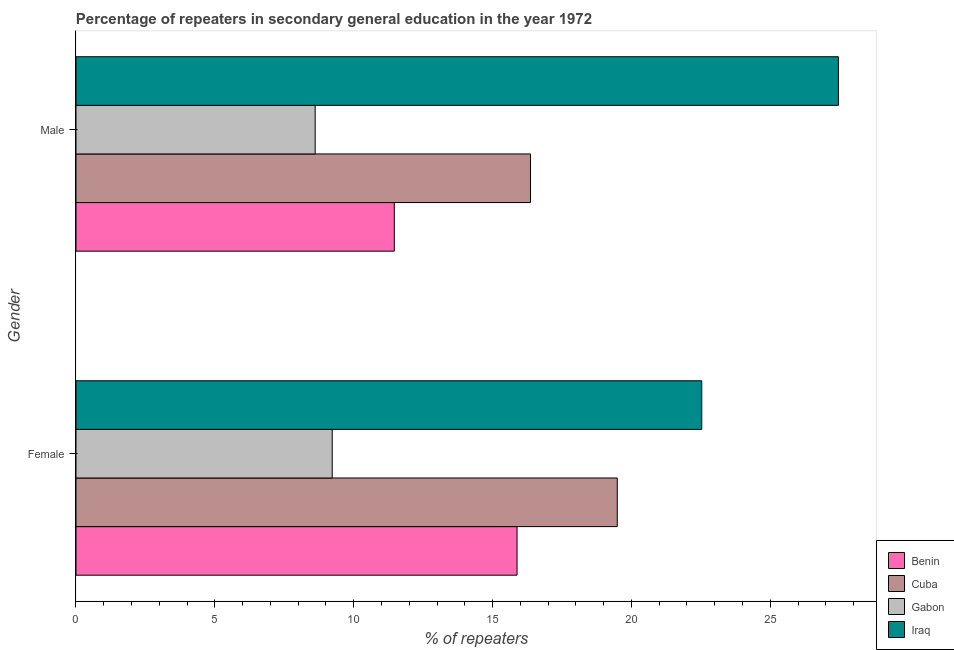How many different coloured bars are there?
Make the answer very short. 4. How many groups of bars are there?
Keep it short and to the point. 2. What is the percentage of male repeaters in Benin?
Offer a terse response. 11.46. Across all countries, what is the maximum percentage of female repeaters?
Provide a short and direct response. 22.53. Across all countries, what is the minimum percentage of male repeaters?
Your answer should be compact. 8.61. In which country was the percentage of female repeaters maximum?
Make the answer very short. Iraq. In which country was the percentage of female repeaters minimum?
Make the answer very short. Gabon. What is the total percentage of male repeaters in the graph?
Your answer should be very brief. 63.89. What is the difference between the percentage of female repeaters in Cuba and that in Benin?
Provide a short and direct response. 3.61. What is the difference between the percentage of female repeaters in Cuba and the percentage of male repeaters in Iraq?
Provide a succinct answer. -7.96. What is the average percentage of male repeaters per country?
Offer a very short reply. 15.97. What is the difference between the percentage of female repeaters and percentage of male repeaters in Cuba?
Ensure brevity in your answer.  3.12. In how many countries, is the percentage of male repeaters greater than 24 %?
Give a very brief answer. 1. What is the ratio of the percentage of male repeaters in Cuba to that in Iraq?
Give a very brief answer. 0.6. Is the percentage of male repeaters in Cuba less than that in Iraq?
Your answer should be very brief. Yes. In how many countries, is the percentage of male repeaters greater than the average percentage of male repeaters taken over all countries?
Your answer should be very brief. 2. What does the 1st bar from the top in Male represents?
Ensure brevity in your answer.  Iraq. What does the 4th bar from the bottom in Male represents?
Provide a succinct answer. Iraq. Are all the bars in the graph horizontal?
Your answer should be compact. Yes. What is the difference between two consecutive major ticks on the X-axis?
Keep it short and to the point. 5. How many legend labels are there?
Give a very brief answer. 4. How are the legend labels stacked?
Give a very brief answer. Vertical. What is the title of the graph?
Keep it short and to the point. Percentage of repeaters in secondary general education in the year 1972. What is the label or title of the X-axis?
Provide a succinct answer. % of repeaters. What is the label or title of the Y-axis?
Offer a terse response. Gender. What is the % of repeaters in Benin in Female?
Make the answer very short. 15.88. What is the % of repeaters of Cuba in Female?
Make the answer very short. 19.49. What is the % of repeaters in Gabon in Female?
Ensure brevity in your answer.  9.23. What is the % of repeaters of Iraq in Female?
Keep it short and to the point. 22.53. What is the % of repeaters of Benin in Male?
Offer a very short reply. 11.46. What is the % of repeaters of Cuba in Male?
Your answer should be compact. 16.37. What is the % of repeaters of Gabon in Male?
Offer a very short reply. 8.61. What is the % of repeaters in Iraq in Male?
Keep it short and to the point. 27.45. Across all Gender, what is the maximum % of repeaters of Benin?
Offer a terse response. 15.88. Across all Gender, what is the maximum % of repeaters of Cuba?
Provide a short and direct response. 19.49. Across all Gender, what is the maximum % of repeaters of Gabon?
Provide a short and direct response. 9.23. Across all Gender, what is the maximum % of repeaters in Iraq?
Offer a very short reply. 27.45. Across all Gender, what is the minimum % of repeaters in Benin?
Offer a very short reply. 11.46. Across all Gender, what is the minimum % of repeaters in Cuba?
Provide a succinct answer. 16.37. Across all Gender, what is the minimum % of repeaters in Gabon?
Your response must be concise. 8.61. Across all Gender, what is the minimum % of repeaters in Iraq?
Keep it short and to the point. 22.53. What is the total % of repeaters in Benin in the graph?
Your response must be concise. 27.34. What is the total % of repeaters in Cuba in the graph?
Offer a terse response. 35.86. What is the total % of repeaters in Gabon in the graph?
Make the answer very short. 17.84. What is the total % of repeaters of Iraq in the graph?
Your answer should be compact. 49.98. What is the difference between the % of repeaters in Benin in Female and that in Male?
Give a very brief answer. 4.42. What is the difference between the % of repeaters in Cuba in Female and that in Male?
Ensure brevity in your answer.  3.12. What is the difference between the % of repeaters in Gabon in Female and that in Male?
Give a very brief answer. 0.61. What is the difference between the % of repeaters in Iraq in Female and that in Male?
Make the answer very short. -4.92. What is the difference between the % of repeaters of Benin in Female and the % of repeaters of Cuba in Male?
Offer a very short reply. -0.48. What is the difference between the % of repeaters in Benin in Female and the % of repeaters in Gabon in Male?
Ensure brevity in your answer.  7.27. What is the difference between the % of repeaters in Benin in Female and the % of repeaters in Iraq in Male?
Your response must be concise. -11.57. What is the difference between the % of repeaters in Cuba in Female and the % of repeaters in Gabon in Male?
Your answer should be compact. 10.88. What is the difference between the % of repeaters in Cuba in Female and the % of repeaters in Iraq in Male?
Your answer should be compact. -7.96. What is the difference between the % of repeaters of Gabon in Female and the % of repeaters of Iraq in Male?
Your response must be concise. -18.23. What is the average % of repeaters in Benin per Gender?
Your answer should be compact. 13.67. What is the average % of repeaters in Cuba per Gender?
Provide a short and direct response. 17.93. What is the average % of repeaters of Gabon per Gender?
Your answer should be very brief. 8.92. What is the average % of repeaters of Iraq per Gender?
Give a very brief answer. 24.99. What is the difference between the % of repeaters of Benin and % of repeaters of Cuba in Female?
Offer a terse response. -3.61. What is the difference between the % of repeaters of Benin and % of repeaters of Gabon in Female?
Offer a very short reply. 6.65. What is the difference between the % of repeaters in Benin and % of repeaters in Iraq in Female?
Provide a succinct answer. -6.65. What is the difference between the % of repeaters in Cuba and % of repeaters in Gabon in Female?
Make the answer very short. 10.26. What is the difference between the % of repeaters of Cuba and % of repeaters of Iraq in Female?
Your answer should be very brief. -3.04. What is the difference between the % of repeaters in Gabon and % of repeaters in Iraq in Female?
Provide a succinct answer. -13.31. What is the difference between the % of repeaters in Benin and % of repeaters in Cuba in Male?
Keep it short and to the point. -4.9. What is the difference between the % of repeaters in Benin and % of repeaters in Gabon in Male?
Provide a succinct answer. 2.85. What is the difference between the % of repeaters in Benin and % of repeaters in Iraq in Male?
Offer a terse response. -15.99. What is the difference between the % of repeaters in Cuba and % of repeaters in Gabon in Male?
Provide a short and direct response. 7.75. What is the difference between the % of repeaters of Cuba and % of repeaters of Iraq in Male?
Provide a short and direct response. -11.09. What is the difference between the % of repeaters of Gabon and % of repeaters of Iraq in Male?
Provide a succinct answer. -18.84. What is the ratio of the % of repeaters of Benin in Female to that in Male?
Provide a succinct answer. 1.39. What is the ratio of the % of repeaters in Cuba in Female to that in Male?
Offer a very short reply. 1.19. What is the ratio of the % of repeaters in Gabon in Female to that in Male?
Provide a succinct answer. 1.07. What is the ratio of the % of repeaters in Iraq in Female to that in Male?
Make the answer very short. 0.82. What is the difference between the highest and the second highest % of repeaters of Benin?
Your response must be concise. 4.42. What is the difference between the highest and the second highest % of repeaters in Cuba?
Your response must be concise. 3.12. What is the difference between the highest and the second highest % of repeaters in Gabon?
Ensure brevity in your answer.  0.61. What is the difference between the highest and the second highest % of repeaters in Iraq?
Your answer should be very brief. 4.92. What is the difference between the highest and the lowest % of repeaters in Benin?
Keep it short and to the point. 4.42. What is the difference between the highest and the lowest % of repeaters in Cuba?
Ensure brevity in your answer.  3.12. What is the difference between the highest and the lowest % of repeaters of Gabon?
Provide a short and direct response. 0.61. What is the difference between the highest and the lowest % of repeaters in Iraq?
Keep it short and to the point. 4.92. 